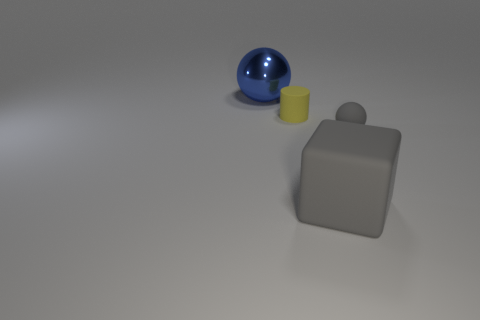There is a matte object that is the same color as the big matte cube; what shape is it?
Offer a terse response. Sphere. Is there a rubber ball that has the same color as the big cube?
Your answer should be very brief. Yes. There is another object that is the same color as the big matte object; what size is it?
Provide a short and direct response. Small. Does the blue shiny thing have the same shape as the tiny gray rubber thing?
Provide a succinct answer. Yes. Is the size of the metallic sphere the same as the cylinder?
Offer a terse response. No. What material is the gray object that is on the right side of the big object that is on the right side of the blue shiny ball?
Your answer should be compact. Rubber. How many other small cubes have the same color as the cube?
Your answer should be very brief. 0. Are there any other things that have the same material as the blue ball?
Make the answer very short. No. Is the number of large balls that are behind the blue metallic object less than the number of small matte balls?
Keep it short and to the point. Yes. What color is the ball that is on the right side of the thing that is on the left side of the small yellow cylinder?
Give a very brief answer. Gray. 